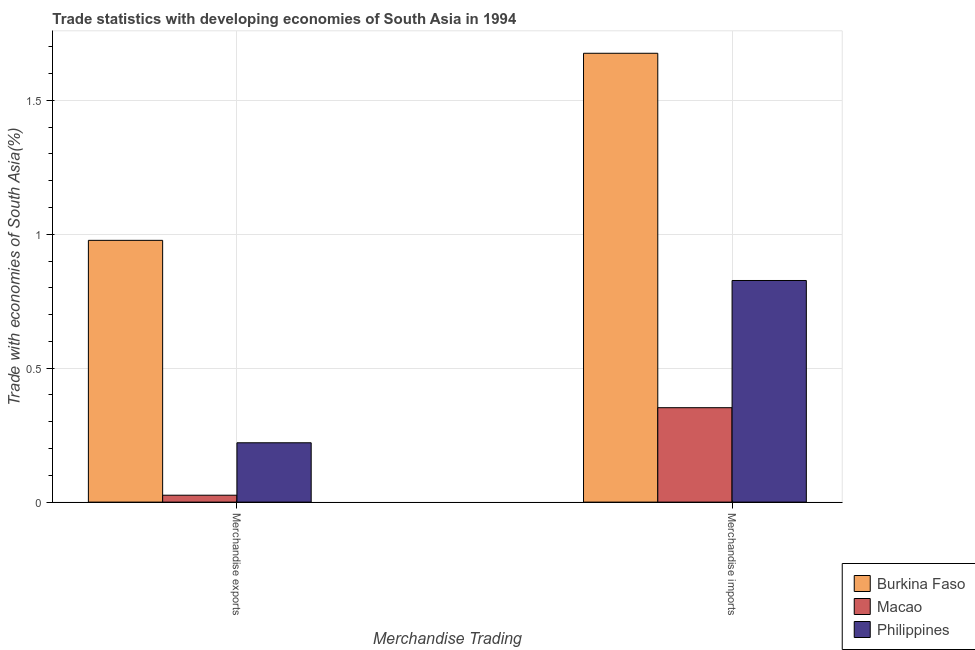How many groups of bars are there?
Provide a short and direct response. 2. Are the number of bars per tick equal to the number of legend labels?
Your response must be concise. Yes. How many bars are there on the 2nd tick from the left?
Ensure brevity in your answer.  3. What is the merchandise imports in Macao?
Offer a terse response. 0.35. Across all countries, what is the maximum merchandise imports?
Your answer should be compact. 1.68. Across all countries, what is the minimum merchandise imports?
Offer a very short reply. 0.35. In which country was the merchandise imports maximum?
Ensure brevity in your answer.  Burkina Faso. In which country was the merchandise imports minimum?
Your answer should be very brief. Macao. What is the total merchandise exports in the graph?
Your answer should be compact. 1.22. What is the difference between the merchandise exports in Burkina Faso and that in Philippines?
Provide a short and direct response. 0.76. What is the difference between the merchandise exports in Macao and the merchandise imports in Philippines?
Give a very brief answer. -0.8. What is the average merchandise exports per country?
Provide a short and direct response. 0.41. What is the difference between the merchandise exports and merchandise imports in Macao?
Provide a succinct answer. -0.33. In how many countries, is the merchandise exports greater than 1.6 %?
Offer a very short reply. 0. What is the ratio of the merchandise imports in Macao to that in Burkina Faso?
Provide a short and direct response. 0.21. Is the merchandise imports in Burkina Faso less than that in Philippines?
Your answer should be very brief. No. How many bars are there?
Provide a short and direct response. 6. How many countries are there in the graph?
Provide a succinct answer. 3. What is the difference between two consecutive major ticks on the Y-axis?
Your answer should be very brief. 0.5. Where does the legend appear in the graph?
Offer a very short reply. Bottom right. How are the legend labels stacked?
Offer a terse response. Vertical. What is the title of the graph?
Ensure brevity in your answer.  Trade statistics with developing economies of South Asia in 1994. Does "Thailand" appear as one of the legend labels in the graph?
Ensure brevity in your answer.  No. What is the label or title of the X-axis?
Your answer should be compact. Merchandise Trading. What is the label or title of the Y-axis?
Provide a succinct answer. Trade with economies of South Asia(%). What is the Trade with economies of South Asia(%) of Burkina Faso in Merchandise exports?
Provide a succinct answer. 0.98. What is the Trade with economies of South Asia(%) in Macao in Merchandise exports?
Ensure brevity in your answer.  0.03. What is the Trade with economies of South Asia(%) of Philippines in Merchandise exports?
Provide a short and direct response. 0.22. What is the Trade with economies of South Asia(%) of Burkina Faso in Merchandise imports?
Your answer should be very brief. 1.68. What is the Trade with economies of South Asia(%) in Macao in Merchandise imports?
Make the answer very short. 0.35. What is the Trade with economies of South Asia(%) of Philippines in Merchandise imports?
Offer a very short reply. 0.83. Across all Merchandise Trading, what is the maximum Trade with economies of South Asia(%) in Burkina Faso?
Offer a very short reply. 1.68. Across all Merchandise Trading, what is the maximum Trade with economies of South Asia(%) in Macao?
Provide a short and direct response. 0.35. Across all Merchandise Trading, what is the maximum Trade with economies of South Asia(%) in Philippines?
Provide a succinct answer. 0.83. Across all Merchandise Trading, what is the minimum Trade with economies of South Asia(%) in Burkina Faso?
Offer a terse response. 0.98. Across all Merchandise Trading, what is the minimum Trade with economies of South Asia(%) in Macao?
Offer a terse response. 0.03. Across all Merchandise Trading, what is the minimum Trade with economies of South Asia(%) in Philippines?
Keep it short and to the point. 0.22. What is the total Trade with economies of South Asia(%) in Burkina Faso in the graph?
Offer a terse response. 2.65. What is the total Trade with economies of South Asia(%) in Macao in the graph?
Give a very brief answer. 0.38. What is the total Trade with economies of South Asia(%) in Philippines in the graph?
Give a very brief answer. 1.05. What is the difference between the Trade with economies of South Asia(%) in Burkina Faso in Merchandise exports and that in Merchandise imports?
Offer a very short reply. -0.7. What is the difference between the Trade with economies of South Asia(%) of Macao in Merchandise exports and that in Merchandise imports?
Your response must be concise. -0.33. What is the difference between the Trade with economies of South Asia(%) of Philippines in Merchandise exports and that in Merchandise imports?
Keep it short and to the point. -0.61. What is the difference between the Trade with economies of South Asia(%) in Burkina Faso in Merchandise exports and the Trade with economies of South Asia(%) in Macao in Merchandise imports?
Provide a short and direct response. 0.62. What is the difference between the Trade with economies of South Asia(%) of Burkina Faso in Merchandise exports and the Trade with economies of South Asia(%) of Philippines in Merchandise imports?
Your answer should be compact. 0.15. What is the difference between the Trade with economies of South Asia(%) of Macao in Merchandise exports and the Trade with economies of South Asia(%) of Philippines in Merchandise imports?
Provide a short and direct response. -0.8. What is the average Trade with economies of South Asia(%) of Burkina Faso per Merchandise Trading?
Your response must be concise. 1.33. What is the average Trade with economies of South Asia(%) of Macao per Merchandise Trading?
Keep it short and to the point. 0.19. What is the average Trade with economies of South Asia(%) in Philippines per Merchandise Trading?
Your response must be concise. 0.52. What is the difference between the Trade with economies of South Asia(%) in Burkina Faso and Trade with economies of South Asia(%) in Macao in Merchandise exports?
Your answer should be compact. 0.95. What is the difference between the Trade with economies of South Asia(%) in Burkina Faso and Trade with economies of South Asia(%) in Philippines in Merchandise exports?
Ensure brevity in your answer.  0.76. What is the difference between the Trade with economies of South Asia(%) of Macao and Trade with economies of South Asia(%) of Philippines in Merchandise exports?
Provide a succinct answer. -0.2. What is the difference between the Trade with economies of South Asia(%) of Burkina Faso and Trade with economies of South Asia(%) of Macao in Merchandise imports?
Your answer should be very brief. 1.32. What is the difference between the Trade with economies of South Asia(%) of Burkina Faso and Trade with economies of South Asia(%) of Philippines in Merchandise imports?
Ensure brevity in your answer.  0.85. What is the difference between the Trade with economies of South Asia(%) of Macao and Trade with economies of South Asia(%) of Philippines in Merchandise imports?
Keep it short and to the point. -0.47. What is the ratio of the Trade with economies of South Asia(%) in Burkina Faso in Merchandise exports to that in Merchandise imports?
Make the answer very short. 0.58. What is the ratio of the Trade with economies of South Asia(%) of Macao in Merchandise exports to that in Merchandise imports?
Make the answer very short. 0.07. What is the ratio of the Trade with economies of South Asia(%) of Philippines in Merchandise exports to that in Merchandise imports?
Provide a short and direct response. 0.27. What is the difference between the highest and the second highest Trade with economies of South Asia(%) in Burkina Faso?
Your answer should be very brief. 0.7. What is the difference between the highest and the second highest Trade with economies of South Asia(%) in Macao?
Offer a very short reply. 0.33. What is the difference between the highest and the second highest Trade with economies of South Asia(%) in Philippines?
Make the answer very short. 0.61. What is the difference between the highest and the lowest Trade with economies of South Asia(%) in Burkina Faso?
Your answer should be compact. 0.7. What is the difference between the highest and the lowest Trade with economies of South Asia(%) of Macao?
Offer a very short reply. 0.33. What is the difference between the highest and the lowest Trade with economies of South Asia(%) of Philippines?
Offer a very short reply. 0.61. 